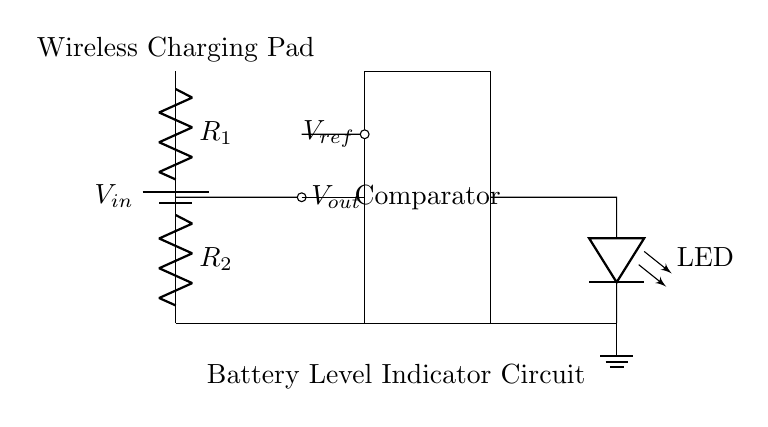What is the source voltage of this circuit? The source voltage is indicated as V_{in} at the battery component at the top of the circuit diagram.
Answer: V_{in} What type of resistors are used in this circuit? The circuit uses two resistors labeled R1 and R2. These are typical passive components used in a voltage divider.
Answer: Resistors What is the output voltage? The output voltage, V_{out}, is taken from the junction between R1 and R2, which is a characteristic feature of a voltage divider circuit.
Answer: V_{out} What role does the comparator play in this circuit? The comparator compares V_{out} against a reference voltage, V_{ref}, to determine if the output should indicate a charge state, often turning an LED on or off based on this comparison.
Answer: Charge state indication How does the voltage divider affect V_{out}? The voltage divider formed by R1 and R2 yields a specific fraction of V_{in} at V_{out}, calculated as V_{out} = V_{in} * (R2 / (R1 + R2)), enabling the monitoring of voltage levels proportional to the input.
Answer: Voltage proportional to V_{in} What component indicates the charge status in the circuit? The LED at the output side, which is connected after the comparator, lights up to show the status of the battery level based on the comparator's output.
Answer: LED What is the ground reference in this circuit? The ground reference is shown as a ground symbol beneath the circuit, which connects all components to a common voltage reference, ensuring proper operation of the entire circuit.
Answer: Ground 